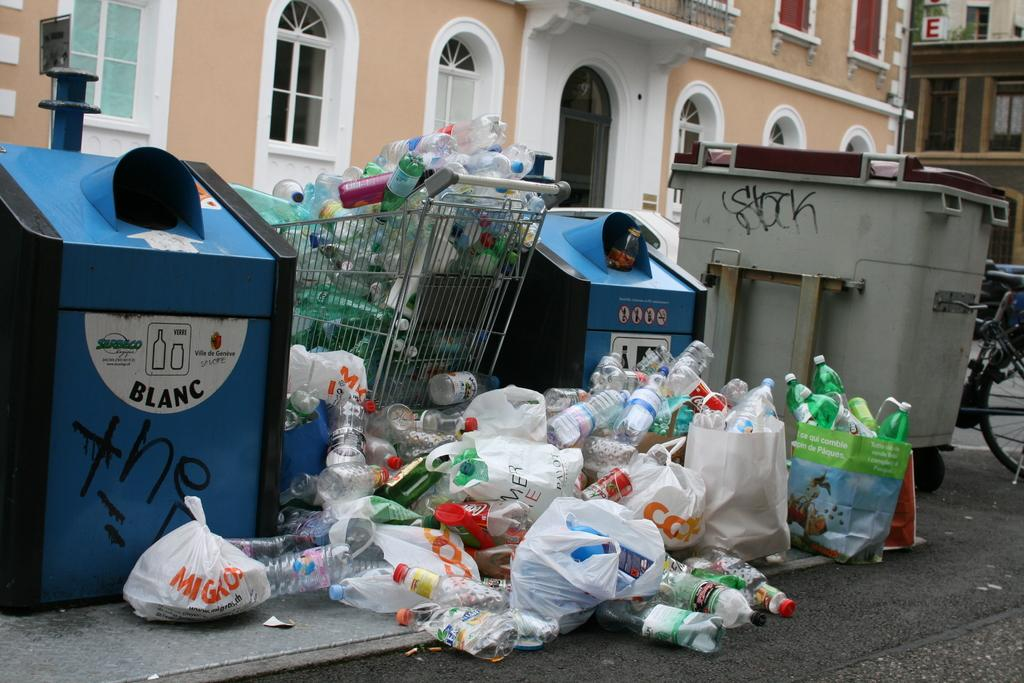<image>
Summarize the visual content of the image. A huge amount of plastic bottles are stacked against recycle bins one of which read Blacn in a French street. 